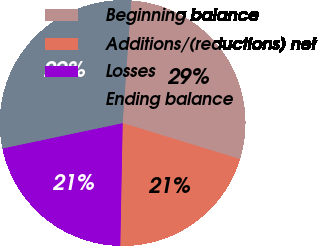<chart> <loc_0><loc_0><loc_500><loc_500><pie_chart><fcel>Beginning balance<fcel>Additions/(reductions) net<fcel>Losses<fcel>Ending balance<nl><fcel>28.62%<fcel>20.57%<fcel>21.38%<fcel>29.43%<nl></chart> 